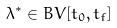<formula> <loc_0><loc_0><loc_500><loc_500>\lambda ^ { * } \in B V [ t _ { 0 } , t _ { f } ]</formula> 